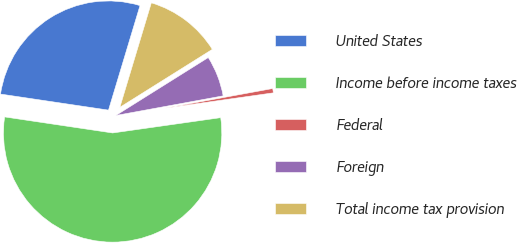<chart> <loc_0><loc_0><loc_500><loc_500><pie_chart><fcel>United States<fcel>Income before income taxes<fcel>Federal<fcel>Foreign<fcel>Total income tax provision<nl><fcel>27.31%<fcel>54.59%<fcel>0.64%<fcel>6.03%<fcel>11.43%<nl></chart> 